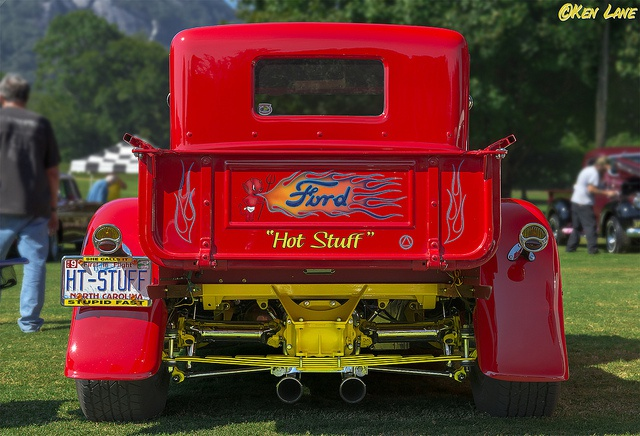Describe the objects in this image and their specific colors. I can see truck in gray, black, brown, and maroon tones, people in gray, black, navy, and darkblue tones, car in gray, black, maroon, and purple tones, people in gray, black, and lavender tones, and people in gray and lightblue tones in this image. 